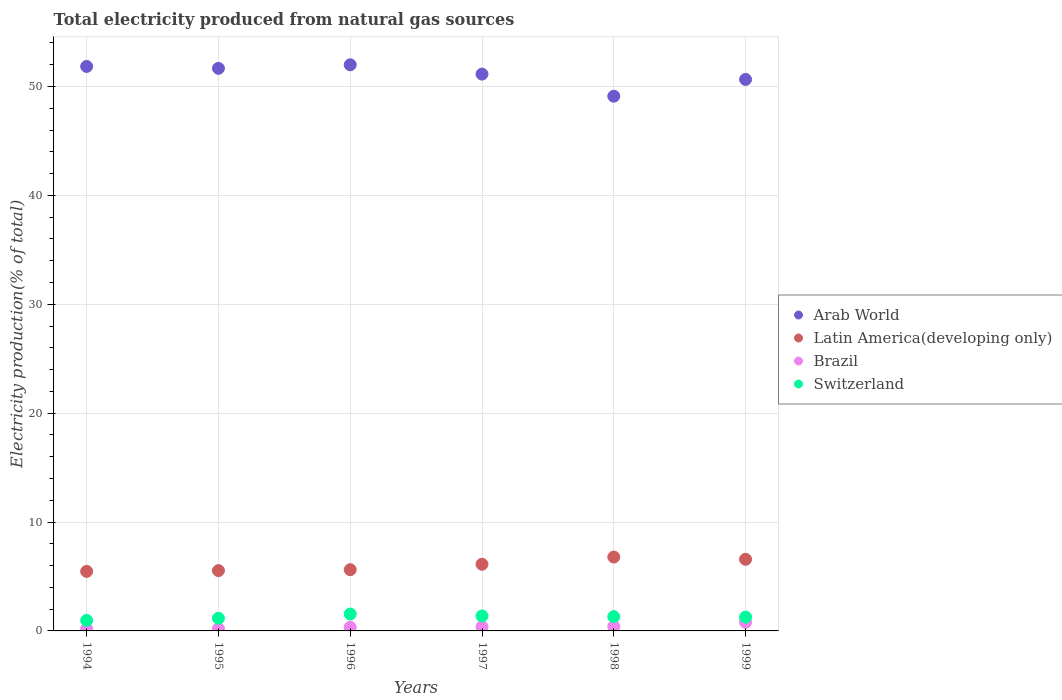How many different coloured dotlines are there?
Offer a terse response. 4. Is the number of dotlines equal to the number of legend labels?
Your response must be concise. Yes. What is the total electricity produced in Arab World in 1997?
Keep it short and to the point. 51.14. Across all years, what is the maximum total electricity produced in Brazil?
Offer a very short reply. 0.79. Across all years, what is the minimum total electricity produced in Latin America(developing only)?
Your answer should be compact. 5.47. In which year was the total electricity produced in Switzerland maximum?
Provide a short and direct response. 1996. In which year was the total electricity produced in Brazil minimum?
Ensure brevity in your answer.  1994. What is the total total electricity produced in Latin America(developing only) in the graph?
Your answer should be compact. 36.11. What is the difference between the total electricity produced in Switzerland in 1997 and that in 1998?
Make the answer very short. 0.06. What is the difference between the total electricity produced in Latin America(developing only) in 1994 and the total electricity produced in Brazil in 1999?
Your response must be concise. 4.68. What is the average total electricity produced in Brazil per year?
Give a very brief answer. 0.38. In the year 1995, what is the difference between the total electricity produced in Switzerland and total electricity produced in Latin America(developing only)?
Offer a very short reply. -4.38. In how many years, is the total electricity produced in Brazil greater than 36 %?
Offer a terse response. 0. What is the ratio of the total electricity produced in Arab World in 1996 to that in 1998?
Offer a terse response. 1.06. Is the total electricity produced in Brazil in 1996 less than that in 1998?
Offer a terse response. Yes. What is the difference between the highest and the second highest total electricity produced in Arab World?
Your answer should be very brief. 0.15. What is the difference between the highest and the lowest total electricity produced in Arab World?
Keep it short and to the point. 2.89. What is the difference between two consecutive major ticks on the Y-axis?
Make the answer very short. 10. Are the values on the major ticks of Y-axis written in scientific E-notation?
Your response must be concise. No. What is the title of the graph?
Make the answer very short. Total electricity produced from natural gas sources. Does "Philippines" appear as one of the legend labels in the graph?
Provide a short and direct response. No. What is the label or title of the X-axis?
Your answer should be compact. Years. What is the label or title of the Y-axis?
Ensure brevity in your answer.  Electricity production(% of total). What is the Electricity production(% of total) in Arab World in 1994?
Keep it short and to the point. 51.84. What is the Electricity production(% of total) in Latin America(developing only) in 1994?
Offer a very short reply. 5.47. What is the Electricity production(% of total) in Brazil in 1994?
Offer a terse response. 0.18. What is the Electricity production(% of total) of Switzerland in 1994?
Make the answer very short. 0.96. What is the Electricity production(% of total) in Arab World in 1995?
Your response must be concise. 51.67. What is the Electricity production(% of total) of Latin America(developing only) in 1995?
Offer a very short reply. 5.54. What is the Electricity production(% of total) of Brazil in 1995?
Your answer should be very brief. 0.2. What is the Electricity production(% of total) of Switzerland in 1995?
Give a very brief answer. 1.16. What is the Electricity production(% of total) of Arab World in 1996?
Offer a very short reply. 51.99. What is the Electricity production(% of total) of Latin America(developing only) in 1996?
Offer a terse response. 5.62. What is the Electricity production(% of total) in Brazil in 1996?
Keep it short and to the point. 0.33. What is the Electricity production(% of total) in Switzerland in 1996?
Your answer should be compact. 1.55. What is the Electricity production(% of total) in Arab World in 1997?
Ensure brevity in your answer.  51.14. What is the Electricity production(% of total) of Latin America(developing only) in 1997?
Make the answer very short. 6.12. What is the Electricity production(% of total) of Brazil in 1997?
Your answer should be very brief. 0.38. What is the Electricity production(% of total) in Switzerland in 1997?
Offer a terse response. 1.37. What is the Electricity production(% of total) in Arab World in 1998?
Provide a short and direct response. 49.11. What is the Electricity production(% of total) in Latin America(developing only) in 1998?
Keep it short and to the point. 6.78. What is the Electricity production(% of total) of Brazil in 1998?
Provide a short and direct response. 0.41. What is the Electricity production(% of total) of Switzerland in 1998?
Provide a succinct answer. 1.31. What is the Electricity production(% of total) in Arab World in 1999?
Make the answer very short. 50.65. What is the Electricity production(% of total) of Latin America(developing only) in 1999?
Your answer should be very brief. 6.58. What is the Electricity production(% of total) of Brazil in 1999?
Your answer should be very brief. 0.79. What is the Electricity production(% of total) in Switzerland in 1999?
Provide a short and direct response. 1.27. Across all years, what is the maximum Electricity production(% of total) in Arab World?
Give a very brief answer. 51.99. Across all years, what is the maximum Electricity production(% of total) of Latin America(developing only)?
Your answer should be very brief. 6.78. Across all years, what is the maximum Electricity production(% of total) of Brazil?
Provide a short and direct response. 0.79. Across all years, what is the maximum Electricity production(% of total) in Switzerland?
Offer a terse response. 1.55. Across all years, what is the minimum Electricity production(% of total) of Arab World?
Make the answer very short. 49.11. Across all years, what is the minimum Electricity production(% of total) in Latin America(developing only)?
Offer a terse response. 5.47. Across all years, what is the minimum Electricity production(% of total) of Brazil?
Provide a succinct answer. 0.18. Across all years, what is the minimum Electricity production(% of total) in Switzerland?
Give a very brief answer. 0.96. What is the total Electricity production(% of total) in Arab World in the graph?
Your answer should be compact. 306.39. What is the total Electricity production(% of total) of Latin America(developing only) in the graph?
Provide a short and direct response. 36.11. What is the total Electricity production(% of total) of Brazil in the graph?
Offer a very short reply. 2.31. What is the total Electricity production(% of total) in Switzerland in the graph?
Your response must be concise. 7.62. What is the difference between the Electricity production(% of total) in Arab World in 1994 and that in 1995?
Your response must be concise. 0.17. What is the difference between the Electricity production(% of total) of Latin America(developing only) in 1994 and that in 1995?
Make the answer very short. -0.07. What is the difference between the Electricity production(% of total) of Brazil in 1994 and that in 1995?
Offer a very short reply. -0.02. What is the difference between the Electricity production(% of total) in Switzerland in 1994 and that in 1995?
Your response must be concise. -0.2. What is the difference between the Electricity production(% of total) in Arab World in 1994 and that in 1996?
Offer a very short reply. -0.15. What is the difference between the Electricity production(% of total) in Latin America(developing only) in 1994 and that in 1996?
Offer a very short reply. -0.15. What is the difference between the Electricity production(% of total) of Brazil in 1994 and that in 1996?
Offer a very short reply. -0.15. What is the difference between the Electricity production(% of total) of Switzerland in 1994 and that in 1996?
Keep it short and to the point. -0.59. What is the difference between the Electricity production(% of total) in Arab World in 1994 and that in 1997?
Keep it short and to the point. 0.7. What is the difference between the Electricity production(% of total) in Latin America(developing only) in 1994 and that in 1997?
Ensure brevity in your answer.  -0.65. What is the difference between the Electricity production(% of total) of Brazil in 1994 and that in 1997?
Make the answer very short. -0.2. What is the difference between the Electricity production(% of total) of Switzerland in 1994 and that in 1997?
Offer a very short reply. -0.41. What is the difference between the Electricity production(% of total) in Arab World in 1994 and that in 1998?
Your answer should be very brief. 2.73. What is the difference between the Electricity production(% of total) in Latin America(developing only) in 1994 and that in 1998?
Your answer should be compact. -1.32. What is the difference between the Electricity production(% of total) in Brazil in 1994 and that in 1998?
Provide a short and direct response. -0.23. What is the difference between the Electricity production(% of total) in Switzerland in 1994 and that in 1998?
Make the answer very short. -0.35. What is the difference between the Electricity production(% of total) of Arab World in 1994 and that in 1999?
Your answer should be compact. 1.19. What is the difference between the Electricity production(% of total) in Latin America(developing only) in 1994 and that in 1999?
Make the answer very short. -1.11. What is the difference between the Electricity production(% of total) in Brazil in 1994 and that in 1999?
Your response must be concise. -0.61. What is the difference between the Electricity production(% of total) of Switzerland in 1994 and that in 1999?
Your answer should be compact. -0.31. What is the difference between the Electricity production(% of total) in Arab World in 1995 and that in 1996?
Provide a succinct answer. -0.33. What is the difference between the Electricity production(% of total) in Latin America(developing only) in 1995 and that in 1996?
Your answer should be compact. -0.08. What is the difference between the Electricity production(% of total) of Brazil in 1995 and that in 1996?
Ensure brevity in your answer.  -0.13. What is the difference between the Electricity production(% of total) in Switzerland in 1995 and that in 1996?
Give a very brief answer. -0.39. What is the difference between the Electricity production(% of total) in Arab World in 1995 and that in 1997?
Your response must be concise. 0.53. What is the difference between the Electricity production(% of total) of Latin America(developing only) in 1995 and that in 1997?
Your response must be concise. -0.58. What is the difference between the Electricity production(% of total) in Brazil in 1995 and that in 1997?
Your answer should be compact. -0.18. What is the difference between the Electricity production(% of total) in Switzerland in 1995 and that in 1997?
Keep it short and to the point. -0.21. What is the difference between the Electricity production(% of total) of Arab World in 1995 and that in 1998?
Give a very brief answer. 2.56. What is the difference between the Electricity production(% of total) in Latin America(developing only) in 1995 and that in 1998?
Provide a succinct answer. -1.25. What is the difference between the Electricity production(% of total) of Brazil in 1995 and that in 1998?
Keep it short and to the point. -0.21. What is the difference between the Electricity production(% of total) of Switzerland in 1995 and that in 1998?
Keep it short and to the point. -0.15. What is the difference between the Electricity production(% of total) in Arab World in 1995 and that in 1999?
Make the answer very short. 1.02. What is the difference between the Electricity production(% of total) of Latin America(developing only) in 1995 and that in 1999?
Provide a short and direct response. -1.04. What is the difference between the Electricity production(% of total) in Brazil in 1995 and that in 1999?
Ensure brevity in your answer.  -0.59. What is the difference between the Electricity production(% of total) of Switzerland in 1995 and that in 1999?
Your answer should be very brief. -0.11. What is the difference between the Electricity production(% of total) of Arab World in 1996 and that in 1997?
Ensure brevity in your answer.  0.86. What is the difference between the Electricity production(% of total) of Latin America(developing only) in 1996 and that in 1997?
Provide a succinct answer. -0.5. What is the difference between the Electricity production(% of total) of Brazil in 1996 and that in 1997?
Offer a very short reply. -0.05. What is the difference between the Electricity production(% of total) in Switzerland in 1996 and that in 1997?
Provide a succinct answer. 0.18. What is the difference between the Electricity production(% of total) in Arab World in 1996 and that in 1998?
Keep it short and to the point. 2.89. What is the difference between the Electricity production(% of total) in Latin America(developing only) in 1996 and that in 1998?
Your answer should be compact. -1.16. What is the difference between the Electricity production(% of total) in Brazil in 1996 and that in 1998?
Keep it short and to the point. -0.08. What is the difference between the Electricity production(% of total) in Switzerland in 1996 and that in 1998?
Your response must be concise. 0.24. What is the difference between the Electricity production(% of total) of Arab World in 1996 and that in 1999?
Provide a succinct answer. 1.35. What is the difference between the Electricity production(% of total) in Latin America(developing only) in 1996 and that in 1999?
Keep it short and to the point. -0.96. What is the difference between the Electricity production(% of total) in Brazil in 1996 and that in 1999?
Make the answer very short. -0.46. What is the difference between the Electricity production(% of total) in Switzerland in 1996 and that in 1999?
Offer a terse response. 0.29. What is the difference between the Electricity production(% of total) in Arab World in 1997 and that in 1998?
Provide a succinct answer. 2.03. What is the difference between the Electricity production(% of total) of Latin America(developing only) in 1997 and that in 1998?
Ensure brevity in your answer.  -0.66. What is the difference between the Electricity production(% of total) of Brazil in 1997 and that in 1998?
Provide a short and direct response. -0.03. What is the difference between the Electricity production(% of total) of Switzerland in 1997 and that in 1998?
Offer a very short reply. 0.06. What is the difference between the Electricity production(% of total) of Arab World in 1997 and that in 1999?
Offer a very short reply. 0.49. What is the difference between the Electricity production(% of total) of Latin America(developing only) in 1997 and that in 1999?
Your answer should be very brief. -0.46. What is the difference between the Electricity production(% of total) of Brazil in 1997 and that in 1999?
Your answer should be compact. -0.41. What is the difference between the Electricity production(% of total) of Switzerland in 1997 and that in 1999?
Keep it short and to the point. 0.11. What is the difference between the Electricity production(% of total) of Arab World in 1998 and that in 1999?
Give a very brief answer. -1.54. What is the difference between the Electricity production(% of total) of Latin America(developing only) in 1998 and that in 1999?
Make the answer very short. 0.21. What is the difference between the Electricity production(% of total) of Brazil in 1998 and that in 1999?
Your response must be concise. -0.38. What is the difference between the Electricity production(% of total) in Switzerland in 1998 and that in 1999?
Make the answer very short. 0.04. What is the difference between the Electricity production(% of total) of Arab World in 1994 and the Electricity production(% of total) of Latin America(developing only) in 1995?
Offer a terse response. 46.3. What is the difference between the Electricity production(% of total) in Arab World in 1994 and the Electricity production(% of total) in Brazil in 1995?
Offer a very short reply. 51.64. What is the difference between the Electricity production(% of total) in Arab World in 1994 and the Electricity production(% of total) in Switzerland in 1995?
Provide a short and direct response. 50.68. What is the difference between the Electricity production(% of total) in Latin America(developing only) in 1994 and the Electricity production(% of total) in Brazil in 1995?
Offer a terse response. 5.27. What is the difference between the Electricity production(% of total) in Latin America(developing only) in 1994 and the Electricity production(% of total) in Switzerland in 1995?
Give a very brief answer. 4.31. What is the difference between the Electricity production(% of total) of Brazil in 1994 and the Electricity production(% of total) of Switzerland in 1995?
Provide a short and direct response. -0.98. What is the difference between the Electricity production(% of total) in Arab World in 1994 and the Electricity production(% of total) in Latin America(developing only) in 1996?
Provide a succinct answer. 46.22. What is the difference between the Electricity production(% of total) of Arab World in 1994 and the Electricity production(% of total) of Brazil in 1996?
Offer a very short reply. 51.51. What is the difference between the Electricity production(% of total) in Arab World in 1994 and the Electricity production(% of total) in Switzerland in 1996?
Give a very brief answer. 50.29. What is the difference between the Electricity production(% of total) in Latin America(developing only) in 1994 and the Electricity production(% of total) in Brazil in 1996?
Your answer should be very brief. 5.13. What is the difference between the Electricity production(% of total) of Latin America(developing only) in 1994 and the Electricity production(% of total) of Switzerland in 1996?
Provide a short and direct response. 3.92. What is the difference between the Electricity production(% of total) in Brazil in 1994 and the Electricity production(% of total) in Switzerland in 1996?
Offer a terse response. -1.37. What is the difference between the Electricity production(% of total) of Arab World in 1994 and the Electricity production(% of total) of Latin America(developing only) in 1997?
Offer a terse response. 45.72. What is the difference between the Electricity production(% of total) of Arab World in 1994 and the Electricity production(% of total) of Brazil in 1997?
Offer a very short reply. 51.46. What is the difference between the Electricity production(% of total) of Arab World in 1994 and the Electricity production(% of total) of Switzerland in 1997?
Offer a terse response. 50.47. What is the difference between the Electricity production(% of total) of Latin America(developing only) in 1994 and the Electricity production(% of total) of Brazil in 1997?
Make the answer very short. 5.09. What is the difference between the Electricity production(% of total) of Latin America(developing only) in 1994 and the Electricity production(% of total) of Switzerland in 1997?
Offer a very short reply. 4.1. What is the difference between the Electricity production(% of total) in Brazil in 1994 and the Electricity production(% of total) in Switzerland in 1997?
Your answer should be compact. -1.19. What is the difference between the Electricity production(% of total) of Arab World in 1994 and the Electricity production(% of total) of Latin America(developing only) in 1998?
Ensure brevity in your answer.  45.06. What is the difference between the Electricity production(% of total) of Arab World in 1994 and the Electricity production(% of total) of Brazil in 1998?
Ensure brevity in your answer.  51.43. What is the difference between the Electricity production(% of total) of Arab World in 1994 and the Electricity production(% of total) of Switzerland in 1998?
Offer a very short reply. 50.53. What is the difference between the Electricity production(% of total) of Latin America(developing only) in 1994 and the Electricity production(% of total) of Brazil in 1998?
Provide a succinct answer. 5.06. What is the difference between the Electricity production(% of total) in Latin America(developing only) in 1994 and the Electricity production(% of total) in Switzerland in 1998?
Offer a terse response. 4.16. What is the difference between the Electricity production(% of total) in Brazil in 1994 and the Electricity production(% of total) in Switzerland in 1998?
Provide a short and direct response. -1.12. What is the difference between the Electricity production(% of total) of Arab World in 1994 and the Electricity production(% of total) of Latin America(developing only) in 1999?
Provide a short and direct response. 45.26. What is the difference between the Electricity production(% of total) of Arab World in 1994 and the Electricity production(% of total) of Brazil in 1999?
Provide a succinct answer. 51.05. What is the difference between the Electricity production(% of total) in Arab World in 1994 and the Electricity production(% of total) in Switzerland in 1999?
Make the answer very short. 50.57. What is the difference between the Electricity production(% of total) of Latin America(developing only) in 1994 and the Electricity production(% of total) of Brazil in 1999?
Give a very brief answer. 4.68. What is the difference between the Electricity production(% of total) in Latin America(developing only) in 1994 and the Electricity production(% of total) in Switzerland in 1999?
Offer a very short reply. 4.2. What is the difference between the Electricity production(% of total) in Brazil in 1994 and the Electricity production(% of total) in Switzerland in 1999?
Keep it short and to the point. -1.08. What is the difference between the Electricity production(% of total) in Arab World in 1995 and the Electricity production(% of total) in Latin America(developing only) in 1996?
Provide a short and direct response. 46.04. What is the difference between the Electricity production(% of total) of Arab World in 1995 and the Electricity production(% of total) of Brazil in 1996?
Make the answer very short. 51.33. What is the difference between the Electricity production(% of total) of Arab World in 1995 and the Electricity production(% of total) of Switzerland in 1996?
Keep it short and to the point. 50.11. What is the difference between the Electricity production(% of total) in Latin America(developing only) in 1995 and the Electricity production(% of total) in Brazil in 1996?
Your response must be concise. 5.2. What is the difference between the Electricity production(% of total) in Latin America(developing only) in 1995 and the Electricity production(% of total) in Switzerland in 1996?
Offer a terse response. 3.99. What is the difference between the Electricity production(% of total) of Brazil in 1995 and the Electricity production(% of total) of Switzerland in 1996?
Your answer should be very brief. -1.35. What is the difference between the Electricity production(% of total) in Arab World in 1995 and the Electricity production(% of total) in Latin America(developing only) in 1997?
Provide a succinct answer. 45.55. What is the difference between the Electricity production(% of total) in Arab World in 1995 and the Electricity production(% of total) in Brazil in 1997?
Your answer should be compact. 51.28. What is the difference between the Electricity production(% of total) in Arab World in 1995 and the Electricity production(% of total) in Switzerland in 1997?
Keep it short and to the point. 50.29. What is the difference between the Electricity production(% of total) in Latin America(developing only) in 1995 and the Electricity production(% of total) in Brazil in 1997?
Make the answer very short. 5.16. What is the difference between the Electricity production(% of total) in Latin America(developing only) in 1995 and the Electricity production(% of total) in Switzerland in 1997?
Offer a very short reply. 4.17. What is the difference between the Electricity production(% of total) of Brazil in 1995 and the Electricity production(% of total) of Switzerland in 1997?
Offer a very short reply. -1.17. What is the difference between the Electricity production(% of total) in Arab World in 1995 and the Electricity production(% of total) in Latin America(developing only) in 1998?
Your answer should be very brief. 44.88. What is the difference between the Electricity production(% of total) of Arab World in 1995 and the Electricity production(% of total) of Brazil in 1998?
Your response must be concise. 51.26. What is the difference between the Electricity production(% of total) of Arab World in 1995 and the Electricity production(% of total) of Switzerland in 1998?
Give a very brief answer. 50.36. What is the difference between the Electricity production(% of total) of Latin America(developing only) in 1995 and the Electricity production(% of total) of Brazil in 1998?
Make the answer very short. 5.13. What is the difference between the Electricity production(% of total) in Latin America(developing only) in 1995 and the Electricity production(% of total) in Switzerland in 1998?
Keep it short and to the point. 4.23. What is the difference between the Electricity production(% of total) in Brazil in 1995 and the Electricity production(% of total) in Switzerland in 1998?
Your answer should be very brief. -1.1. What is the difference between the Electricity production(% of total) in Arab World in 1995 and the Electricity production(% of total) in Latin America(developing only) in 1999?
Offer a terse response. 45.09. What is the difference between the Electricity production(% of total) in Arab World in 1995 and the Electricity production(% of total) in Brazil in 1999?
Make the answer very short. 50.87. What is the difference between the Electricity production(% of total) of Arab World in 1995 and the Electricity production(% of total) of Switzerland in 1999?
Keep it short and to the point. 50.4. What is the difference between the Electricity production(% of total) in Latin America(developing only) in 1995 and the Electricity production(% of total) in Brazil in 1999?
Your answer should be compact. 4.75. What is the difference between the Electricity production(% of total) of Latin America(developing only) in 1995 and the Electricity production(% of total) of Switzerland in 1999?
Give a very brief answer. 4.27. What is the difference between the Electricity production(% of total) of Brazil in 1995 and the Electricity production(% of total) of Switzerland in 1999?
Give a very brief answer. -1.06. What is the difference between the Electricity production(% of total) in Arab World in 1996 and the Electricity production(% of total) in Latin America(developing only) in 1997?
Your response must be concise. 45.87. What is the difference between the Electricity production(% of total) in Arab World in 1996 and the Electricity production(% of total) in Brazil in 1997?
Keep it short and to the point. 51.61. What is the difference between the Electricity production(% of total) in Arab World in 1996 and the Electricity production(% of total) in Switzerland in 1997?
Your response must be concise. 50.62. What is the difference between the Electricity production(% of total) of Latin America(developing only) in 1996 and the Electricity production(% of total) of Brazil in 1997?
Your answer should be very brief. 5.24. What is the difference between the Electricity production(% of total) in Latin America(developing only) in 1996 and the Electricity production(% of total) in Switzerland in 1997?
Give a very brief answer. 4.25. What is the difference between the Electricity production(% of total) of Brazil in 1996 and the Electricity production(% of total) of Switzerland in 1997?
Provide a short and direct response. -1.04. What is the difference between the Electricity production(% of total) of Arab World in 1996 and the Electricity production(% of total) of Latin America(developing only) in 1998?
Keep it short and to the point. 45.21. What is the difference between the Electricity production(% of total) of Arab World in 1996 and the Electricity production(% of total) of Brazil in 1998?
Your answer should be very brief. 51.58. What is the difference between the Electricity production(% of total) of Arab World in 1996 and the Electricity production(% of total) of Switzerland in 1998?
Ensure brevity in your answer.  50.68. What is the difference between the Electricity production(% of total) in Latin America(developing only) in 1996 and the Electricity production(% of total) in Brazil in 1998?
Provide a succinct answer. 5.21. What is the difference between the Electricity production(% of total) in Latin America(developing only) in 1996 and the Electricity production(% of total) in Switzerland in 1998?
Provide a short and direct response. 4.31. What is the difference between the Electricity production(% of total) in Brazil in 1996 and the Electricity production(% of total) in Switzerland in 1998?
Your answer should be compact. -0.97. What is the difference between the Electricity production(% of total) of Arab World in 1996 and the Electricity production(% of total) of Latin America(developing only) in 1999?
Give a very brief answer. 45.41. What is the difference between the Electricity production(% of total) of Arab World in 1996 and the Electricity production(% of total) of Brazil in 1999?
Give a very brief answer. 51.2. What is the difference between the Electricity production(% of total) of Arab World in 1996 and the Electricity production(% of total) of Switzerland in 1999?
Your answer should be compact. 50.73. What is the difference between the Electricity production(% of total) in Latin America(developing only) in 1996 and the Electricity production(% of total) in Brazil in 1999?
Make the answer very short. 4.83. What is the difference between the Electricity production(% of total) in Latin America(developing only) in 1996 and the Electricity production(% of total) in Switzerland in 1999?
Provide a short and direct response. 4.36. What is the difference between the Electricity production(% of total) of Brazil in 1996 and the Electricity production(% of total) of Switzerland in 1999?
Give a very brief answer. -0.93. What is the difference between the Electricity production(% of total) in Arab World in 1997 and the Electricity production(% of total) in Latin America(developing only) in 1998?
Ensure brevity in your answer.  44.35. What is the difference between the Electricity production(% of total) in Arab World in 1997 and the Electricity production(% of total) in Brazil in 1998?
Provide a short and direct response. 50.73. What is the difference between the Electricity production(% of total) of Arab World in 1997 and the Electricity production(% of total) of Switzerland in 1998?
Your response must be concise. 49.83. What is the difference between the Electricity production(% of total) in Latin America(developing only) in 1997 and the Electricity production(% of total) in Brazil in 1998?
Offer a terse response. 5.71. What is the difference between the Electricity production(% of total) of Latin America(developing only) in 1997 and the Electricity production(% of total) of Switzerland in 1998?
Provide a succinct answer. 4.81. What is the difference between the Electricity production(% of total) of Brazil in 1997 and the Electricity production(% of total) of Switzerland in 1998?
Provide a short and direct response. -0.93. What is the difference between the Electricity production(% of total) of Arab World in 1997 and the Electricity production(% of total) of Latin America(developing only) in 1999?
Provide a succinct answer. 44.56. What is the difference between the Electricity production(% of total) in Arab World in 1997 and the Electricity production(% of total) in Brazil in 1999?
Provide a short and direct response. 50.34. What is the difference between the Electricity production(% of total) of Arab World in 1997 and the Electricity production(% of total) of Switzerland in 1999?
Your answer should be very brief. 49.87. What is the difference between the Electricity production(% of total) in Latin America(developing only) in 1997 and the Electricity production(% of total) in Brazil in 1999?
Your answer should be very brief. 5.33. What is the difference between the Electricity production(% of total) in Latin America(developing only) in 1997 and the Electricity production(% of total) in Switzerland in 1999?
Offer a terse response. 4.85. What is the difference between the Electricity production(% of total) in Brazil in 1997 and the Electricity production(% of total) in Switzerland in 1999?
Make the answer very short. -0.88. What is the difference between the Electricity production(% of total) of Arab World in 1998 and the Electricity production(% of total) of Latin America(developing only) in 1999?
Ensure brevity in your answer.  42.53. What is the difference between the Electricity production(% of total) of Arab World in 1998 and the Electricity production(% of total) of Brazil in 1999?
Your answer should be compact. 48.31. What is the difference between the Electricity production(% of total) in Arab World in 1998 and the Electricity production(% of total) in Switzerland in 1999?
Keep it short and to the point. 47.84. What is the difference between the Electricity production(% of total) in Latin America(developing only) in 1998 and the Electricity production(% of total) in Brazil in 1999?
Your answer should be compact. 5.99. What is the difference between the Electricity production(% of total) of Latin America(developing only) in 1998 and the Electricity production(% of total) of Switzerland in 1999?
Your answer should be compact. 5.52. What is the difference between the Electricity production(% of total) of Brazil in 1998 and the Electricity production(% of total) of Switzerland in 1999?
Give a very brief answer. -0.86. What is the average Electricity production(% of total) of Arab World per year?
Provide a short and direct response. 51.06. What is the average Electricity production(% of total) in Latin America(developing only) per year?
Your answer should be very brief. 6.02. What is the average Electricity production(% of total) in Brazil per year?
Your answer should be very brief. 0.38. What is the average Electricity production(% of total) in Switzerland per year?
Offer a very short reply. 1.27. In the year 1994, what is the difference between the Electricity production(% of total) of Arab World and Electricity production(% of total) of Latin America(developing only)?
Provide a succinct answer. 46.37. In the year 1994, what is the difference between the Electricity production(% of total) of Arab World and Electricity production(% of total) of Brazil?
Provide a short and direct response. 51.66. In the year 1994, what is the difference between the Electricity production(% of total) of Arab World and Electricity production(% of total) of Switzerland?
Provide a succinct answer. 50.88. In the year 1994, what is the difference between the Electricity production(% of total) in Latin America(developing only) and Electricity production(% of total) in Brazil?
Give a very brief answer. 5.28. In the year 1994, what is the difference between the Electricity production(% of total) of Latin America(developing only) and Electricity production(% of total) of Switzerland?
Offer a very short reply. 4.51. In the year 1994, what is the difference between the Electricity production(% of total) of Brazil and Electricity production(% of total) of Switzerland?
Give a very brief answer. -0.78. In the year 1995, what is the difference between the Electricity production(% of total) in Arab World and Electricity production(% of total) in Latin America(developing only)?
Give a very brief answer. 46.13. In the year 1995, what is the difference between the Electricity production(% of total) of Arab World and Electricity production(% of total) of Brazil?
Provide a short and direct response. 51.46. In the year 1995, what is the difference between the Electricity production(% of total) of Arab World and Electricity production(% of total) of Switzerland?
Your response must be concise. 50.5. In the year 1995, what is the difference between the Electricity production(% of total) of Latin America(developing only) and Electricity production(% of total) of Brazil?
Offer a very short reply. 5.34. In the year 1995, what is the difference between the Electricity production(% of total) in Latin America(developing only) and Electricity production(% of total) in Switzerland?
Ensure brevity in your answer.  4.38. In the year 1995, what is the difference between the Electricity production(% of total) in Brazil and Electricity production(% of total) in Switzerland?
Give a very brief answer. -0.96. In the year 1996, what is the difference between the Electricity production(% of total) of Arab World and Electricity production(% of total) of Latin America(developing only)?
Provide a succinct answer. 46.37. In the year 1996, what is the difference between the Electricity production(% of total) in Arab World and Electricity production(% of total) in Brazil?
Offer a very short reply. 51.66. In the year 1996, what is the difference between the Electricity production(% of total) of Arab World and Electricity production(% of total) of Switzerland?
Make the answer very short. 50.44. In the year 1996, what is the difference between the Electricity production(% of total) of Latin America(developing only) and Electricity production(% of total) of Brazil?
Keep it short and to the point. 5.29. In the year 1996, what is the difference between the Electricity production(% of total) of Latin America(developing only) and Electricity production(% of total) of Switzerland?
Offer a very short reply. 4.07. In the year 1996, what is the difference between the Electricity production(% of total) of Brazil and Electricity production(% of total) of Switzerland?
Offer a terse response. -1.22. In the year 1997, what is the difference between the Electricity production(% of total) in Arab World and Electricity production(% of total) in Latin America(developing only)?
Offer a very short reply. 45.02. In the year 1997, what is the difference between the Electricity production(% of total) of Arab World and Electricity production(% of total) of Brazil?
Give a very brief answer. 50.75. In the year 1997, what is the difference between the Electricity production(% of total) of Arab World and Electricity production(% of total) of Switzerland?
Give a very brief answer. 49.76. In the year 1997, what is the difference between the Electricity production(% of total) in Latin America(developing only) and Electricity production(% of total) in Brazil?
Your answer should be very brief. 5.74. In the year 1997, what is the difference between the Electricity production(% of total) of Latin America(developing only) and Electricity production(% of total) of Switzerland?
Your answer should be compact. 4.75. In the year 1997, what is the difference between the Electricity production(% of total) in Brazil and Electricity production(% of total) in Switzerland?
Keep it short and to the point. -0.99. In the year 1998, what is the difference between the Electricity production(% of total) in Arab World and Electricity production(% of total) in Latin America(developing only)?
Make the answer very short. 42.32. In the year 1998, what is the difference between the Electricity production(% of total) in Arab World and Electricity production(% of total) in Brazil?
Provide a succinct answer. 48.69. In the year 1998, what is the difference between the Electricity production(% of total) of Arab World and Electricity production(% of total) of Switzerland?
Offer a very short reply. 47.8. In the year 1998, what is the difference between the Electricity production(% of total) in Latin America(developing only) and Electricity production(% of total) in Brazil?
Ensure brevity in your answer.  6.37. In the year 1998, what is the difference between the Electricity production(% of total) of Latin America(developing only) and Electricity production(% of total) of Switzerland?
Ensure brevity in your answer.  5.48. In the year 1998, what is the difference between the Electricity production(% of total) in Brazil and Electricity production(% of total) in Switzerland?
Your response must be concise. -0.9. In the year 1999, what is the difference between the Electricity production(% of total) in Arab World and Electricity production(% of total) in Latin America(developing only)?
Ensure brevity in your answer.  44.07. In the year 1999, what is the difference between the Electricity production(% of total) of Arab World and Electricity production(% of total) of Brazil?
Offer a terse response. 49.85. In the year 1999, what is the difference between the Electricity production(% of total) in Arab World and Electricity production(% of total) in Switzerland?
Your answer should be very brief. 49.38. In the year 1999, what is the difference between the Electricity production(% of total) of Latin America(developing only) and Electricity production(% of total) of Brazil?
Your answer should be very brief. 5.79. In the year 1999, what is the difference between the Electricity production(% of total) of Latin America(developing only) and Electricity production(% of total) of Switzerland?
Ensure brevity in your answer.  5.31. In the year 1999, what is the difference between the Electricity production(% of total) in Brazil and Electricity production(% of total) in Switzerland?
Your answer should be compact. -0.47. What is the ratio of the Electricity production(% of total) of Latin America(developing only) in 1994 to that in 1995?
Provide a succinct answer. 0.99. What is the ratio of the Electricity production(% of total) in Brazil in 1994 to that in 1995?
Make the answer very short. 0.91. What is the ratio of the Electricity production(% of total) of Switzerland in 1994 to that in 1995?
Your answer should be compact. 0.83. What is the ratio of the Electricity production(% of total) in Latin America(developing only) in 1994 to that in 1996?
Your answer should be very brief. 0.97. What is the ratio of the Electricity production(% of total) in Brazil in 1994 to that in 1996?
Offer a very short reply. 0.55. What is the ratio of the Electricity production(% of total) of Switzerland in 1994 to that in 1996?
Make the answer very short. 0.62. What is the ratio of the Electricity production(% of total) in Arab World in 1994 to that in 1997?
Offer a terse response. 1.01. What is the ratio of the Electricity production(% of total) in Latin America(developing only) in 1994 to that in 1997?
Ensure brevity in your answer.  0.89. What is the ratio of the Electricity production(% of total) in Brazil in 1994 to that in 1997?
Offer a very short reply. 0.48. What is the ratio of the Electricity production(% of total) in Switzerland in 1994 to that in 1997?
Provide a short and direct response. 0.7. What is the ratio of the Electricity production(% of total) of Arab World in 1994 to that in 1998?
Keep it short and to the point. 1.06. What is the ratio of the Electricity production(% of total) in Latin America(developing only) in 1994 to that in 1998?
Give a very brief answer. 0.81. What is the ratio of the Electricity production(% of total) in Brazil in 1994 to that in 1998?
Keep it short and to the point. 0.45. What is the ratio of the Electricity production(% of total) of Switzerland in 1994 to that in 1998?
Your response must be concise. 0.73. What is the ratio of the Electricity production(% of total) of Arab World in 1994 to that in 1999?
Give a very brief answer. 1.02. What is the ratio of the Electricity production(% of total) of Latin America(developing only) in 1994 to that in 1999?
Keep it short and to the point. 0.83. What is the ratio of the Electricity production(% of total) in Brazil in 1994 to that in 1999?
Provide a succinct answer. 0.23. What is the ratio of the Electricity production(% of total) of Switzerland in 1994 to that in 1999?
Make the answer very short. 0.76. What is the ratio of the Electricity production(% of total) in Arab World in 1995 to that in 1996?
Your answer should be very brief. 0.99. What is the ratio of the Electricity production(% of total) in Brazil in 1995 to that in 1996?
Keep it short and to the point. 0.61. What is the ratio of the Electricity production(% of total) of Switzerland in 1995 to that in 1996?
Provide a short and direct response. 0.75. What is the ratio of the Electricity production(% of total) of Arab World in 1995 to that in 1997?
Your answer should be compact. 1.01. What is the ratio of the Electricity production(% of total) in Latin America(developing only) in 1995 to that in 1997?
Ensure brevity in your answer.  0.9. What is the ratio of the Electricity production(% of total) in Brazil in 1995 to that in 1997?
Provide a short and direct response. 0.53. What is the ratio of the Electricity production(% of total) in Switzerland in 1995 to that in 1997?
Offer a terse response. 0.85. What is the ratio of the Electricity production(% of total) of Arab World in 1995 to that in 1998?
Provide a short and direct response. 1.05. What is the ratio of the Electricity production(% of total) in Latin America(developing only) in 1995 to that in 1998?
Provide a succinct answer. 0.82. What is the ratio of the Electricity production(% of total) in Brazil in 1995 to that in 1998?
Offer a very short reply. 0.49. What is the ratio of the Electricity production(% of total) in Switzerland in 1995 to that in 1998?
Make the answer very short. 0.89. What is the ratio of the Electricity production(% of total) of Arab World in 1995 to that in 1999?
Provide a succinct answer. 1.02. What is the ratio of the Electricity production(% of total) of Latin America(developing only) in 1995 to that in 1999?
Keep it short and to the point. 0.84. What is the ratio of the Electricity production(% of total) of Brazil in 1995 to that in 1999?
Give a very brief answer. 0.26. What is the ratio of the Electricity production(% of total) of Switzerland in 1995 to that in 1999?
Offer a terse response. 0.92. What is the ratio of the Electricity production(% of total) of Arab World in 1996 to that in 1997?
Offer a very short reply. 1.02. What is the ratio of the Electricity production(% of total) of Latin America(developing only) in 1996 to that in 1997?
Provide a succinct answer. 0.92. What is the ratio of the Electricity production(% of total) in Brazil in 1996 to that in 1997?
Make the answer very short. 0.88. What is the ratio of the Electricity production(% of total) in Switzerland in 1996 to that in 1997?
Your response must be concise. 1.13. What is the ratio of the Electricity production(% of total) of Arab World in 1996 to that in 1998?
Give a very brief answer. 1.06. What is the ratio of the Electricity production(% of total) in Latin America(developing only) in 1996 to that in 1998?
Offer a very short reply. 0.83. What is the ratio of the Electricity production(% of total) of Brazil in 1996 to that in 1998?
Offer a very short reply. 0.81. What is the ratio of the Electricity production(% of total) in Switzerland in 1996 to that in 1998?
Provide a succinct answer. 1.19. What is the ratio of the Electricity production(% of total) in Arab World in 1996 to that in 1999?
Your answer should be compact. 1.03. What is the ratio of the Electricity production(% of total) of Latin America(developing only) in 1996 to that in 1999?
Make the answer very short. 0.85. What is the ratio of the Electricity production(% of total) of Brazil in 1996 to that in 1999?
Make the answer very short. 0.42. What is the ratio of the Electricity production(% of total) of Switzerland in 1996 to that in 1999?
Provide a succinct answer. 1.23. What is the ratio of the Electricity production(% of total) in Arab World in 1997 to that in 1998?
Your response must be concise. 1.04. What is the ratio of the Electricity production(% of total) of Latin America(developing only) in 1997 to that in 1998?
Your answer should be compact. 0.9. What is the ratio of the Electricity production(% of total) of Brazil in 1997 to that in 1998?
Your answer should be very brief. 0.93. What is the ratio of the Electricity production(% of total) in Switzerland in 1997 to that in 1998?
Offer a very short reply. 1.05. What is the ratio of the Electricity production(% of total) of Arab World in 1997 to that in 1999?
Your answer should be compact. 1.01. What is the ratio of the Electricity production(% of total) in Latin America(developing only) in 1997 to that in 1999?
Your answer should be very brief. 0.93. What is the ratio of the Electricity production(% of total) of Brazil in 1997 to that in 1999?
Provide a succinct answer. 0.48. What is the ratio of the Electricity production(% of total) in Switzerland in 1997 to that in 1999?
Your answer should be very brief. 1.08. What is the ratio of the Electricity production(% of total) of Arab World in 1998 to that in 1999?
Make the answer very short. 0.97. What is the ratio of the Electricity production(% of total) of Latin America(developing only) in 1998 to that in 1999?
Offer a terse response. 1.03. What is the ratio of the Electricity production(% of total) of Brazil in 1998 to that in 1999?
Keep it short and to the point. 0.52. What is the ratio of the Electricity production(% of total) in Switzerland in 1998 to that in 1999?
Make the answer very short. 1.03. What is the difference between the highest and the second highest Electricity production(% of total) of Arab World?
Offer a very short reply. 0.15. What is the difference between the highest and the second highest Electricity production(% of total) in Latin America(developing only)?
Your answer should be compact. 0.21. What is the difference between the highest and the second highest Electricity production(% of total) in Brazil?
Offer a terse response. 0.38. What is the difference between the highest and the second highest Electricity production(% of total) in Switzerland?
Your answer should be very brief. 0.18. What is the difference between the highest and the lowest Electricity production(% of total) in Arab World?
Your response must be concise. 2.89. What is the difference between the highest and the lowest Electricity production(% of total) of Latin America(developing only)?
Give a very brief answer. 1.32. What is the difference between the highest and the lowest Electricity production(% of total) in Brazil?
Offer a terse response. 0.61. What is the difference between the highest and the lowest Electricity production(% of total) of Switzerland?
Provide a succinct answer. 0.59. 